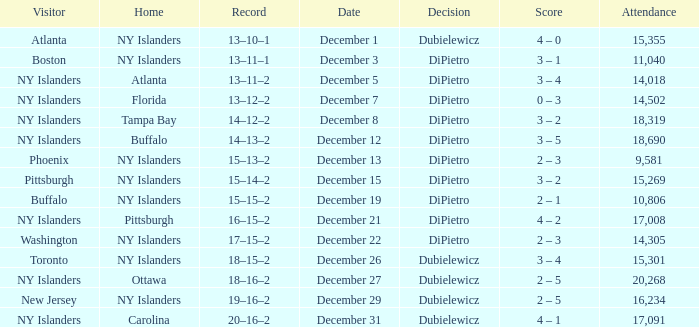Name the date for attendance more than 20,268 None. Could you parse the entire table? {'header': ['Visitor', 'Home', 'Record', 'Date', 'Decision', 'Score', 'Attendance'], 'rows': [['Atlanta', 'NY Islanders', '13–10–1', 'December 1', 'Dubielewicz', '4 – 0', '15,355'], ['Boston', 'NY Islanders', '13–11–1', 'December 3', 'DiPietro', '3 – 1', '11,040'], ['NY Islanders', 'Atlanta', '13–11–2', 'December 5', 'DiPietro', '3 – 4', '14,018'], ['NY Islanders', 'Florida', '13–12–2', 'December 7', 'DiPietro', '0 – 3', '14,502'], ['NY Islanders', 'Tampa Bay', '14–12–2', 'December 8', 'DiPietro', '3 – 2', '18,319'], ['NY Islanders', 'Buffalo', '14–13–2', 'December 12', 'DiPietro', '3 – 5', '18,690'], ['Phoenix', 'NY Islanders', '15–13–2', 'December 13', 'DiPietro', '2 – 3', '9,581'], ['Pittsburgh', 'NY Islanders', '15–14–2', 'December 15', 'DiPietro', '3 – 2', '15,269'], ['Buffalo', 'NY Islanders', '15–15–2', 'December 19', 'DiPietro', '2 – 1', '10,806'], ['NY Islanders', 'Pittsburgh', '16–15–2', 'December 21', 'DiPietro', '4 – 2', '17,008'], ['Washington', 'NY Islanders', '17–15–2', 'December 22', 'DiPietro', '2 – 3', '14,305'], ['Toronto', 'NY Islanders', '18–15–2', 'December 26', 'Dubielewicz', '3 – 4', '15,301'], ['NY Islanders', 'Ottawa', '18–16–2', 'December 27', 'Dubielewicz', '2 – 5', '20,268'], ['New Jersey', 'NY Islanders', '19–16–2', 'December 29', 'Dubielewicz', '2 – 5', '16,234'], ['NY Islanders', 'Carolina', '20–16–2', 'December 31', 'Dubielewicz', '4 – 1', '17,091']]} 